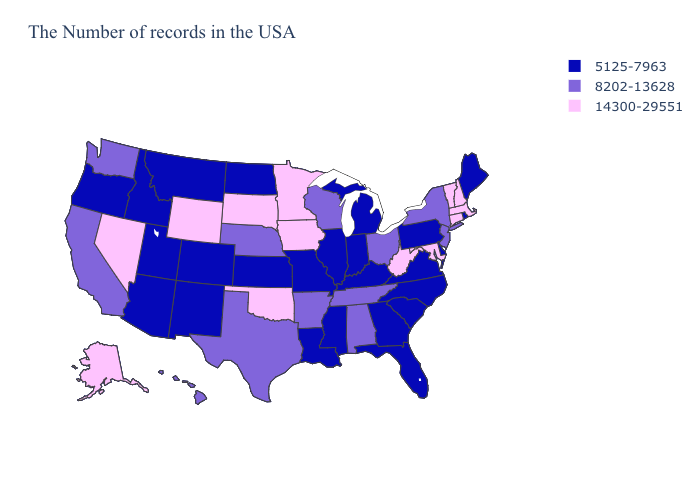What is the value of Maryland?
Give a very brief answer. 14300-29551. Which states have the lowest value in the USA?
Short answer required. Maine, Rhode Island, Delaware, Pennsylvania, Virginia, North Carolina, South Carolina, Florida, Georgia, Michigan, Kentucky, Indiana, Illinois, Mississippi, Louisiana, Missouri, Kansas, North Dakota, Colorado, New Mexico, Utah, Montana, Arizona, Idaho, Oregon. Name the states that have a value in the range 5125-7963?
Be succinct. Maine, Rhode Island, Delaware, Pennsylvania, Virginia, North Carolina, South Carolina, Florida, Georgia, Michigan, Kentucky, Indiana, Illinois, Mississippi, Louisiana, Missouri, Kansas, North Dakota, Colorado, New Mexico, Utah, Montana, Arizona, Idaho, Oregon. Name the states that have a value in the range 14300-29551?
Write a very short answer. Massachusetts, New Hampshire, Vermont, Connecticut, Maryland, West Virginia, Minnesota, Iowa, Oklahoma, South Dakota, Wyoming, Nevada, Alaska. What is the value of Indiana?
Be succinct. 5125-7963. Does West Virginia have the highest value in the South?
Answer briefly. Yes. Name the states that have a value in the range 5125-7963?
Concise answer only. Maine, Rhode Island, Delaware, Pennsylvania, Virginia, North Carolina, South Carolina, Florida, Georgia, Michigan, Kentucky, Indiana, Illinois, Mississippi, Louisiana, Missouri, Kansas, North Dakota, Colorado, New Mexico, Utah, Montana, Arizona, Idaho, Oregon. Does Connecticut have the same value as Florida?
Answer briefly. No. Does Illinois have a lower value than Alabama?
Be succinct. Yes. Name the states that have a value in the range 5125-7963?
Be succinct. Maine, Rhode Island, Delaware, Pennsylvania, Virginia, North Carolina, South Carolina, Florida, Georgia, Michigan, Kentucky, Indiana, Illinois, Mississippi, Louisiana, Missouri, Kansas, North Dakota, Colorado, New Mexico, Utah, Montana, Arizona, Idaho, Oregon. Does Oregon have the lowest value in the West?
Answer briefly. Yes. Does Louisiana have the lowest value in the South?
Concise answer only. Yes. Among the states that border Mississippi , which have the highest value?
Give a very brief answer. Alabama, Tennessee, Arkansas. Among the states that border Georgia , which have the lowest value?
Be succinct. North Carolina, South Carolina, Florida. What is the lowest value in the West?
Keep it brief. 5125-7963. 